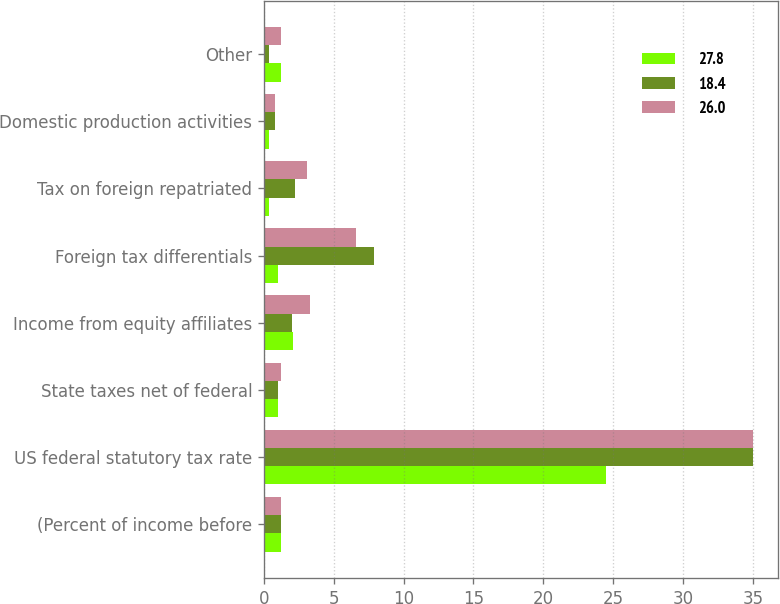Convert chart. <chart><loc_0><loc_0><loc_500><loc_500><stacked_bar_chart><ecel><fcel>(Percent of income before<fcel>US federal statutory tax rate<fcel>State taxes net of federal<fcel>Income from equity affiliates<fcel>Foreign tax differentials<fcel>Tax on foreign repatriated<fcel>Domestic production activities<fcel>Other<nl><fcel>27.8<fcel>1.2<fcel>24.5<fcel>1<fcel>2.1<fcel>1<fcel>0.4<fcel>0.4<fcel>1.2<nl><fcel>18.4<fcel>1.2<fcel>35<fcel>1<fcel>2<fcel>7.9<fcel>2.2<fcel>0.8<fcel>0.4<nl><fcel>26<fcel>1.2<fcel>35<fcel>1.2<fcel>3.3<fcel>6.6<fcel>3.1<fcel>0.8<fcel>1.2<nl></chart> 